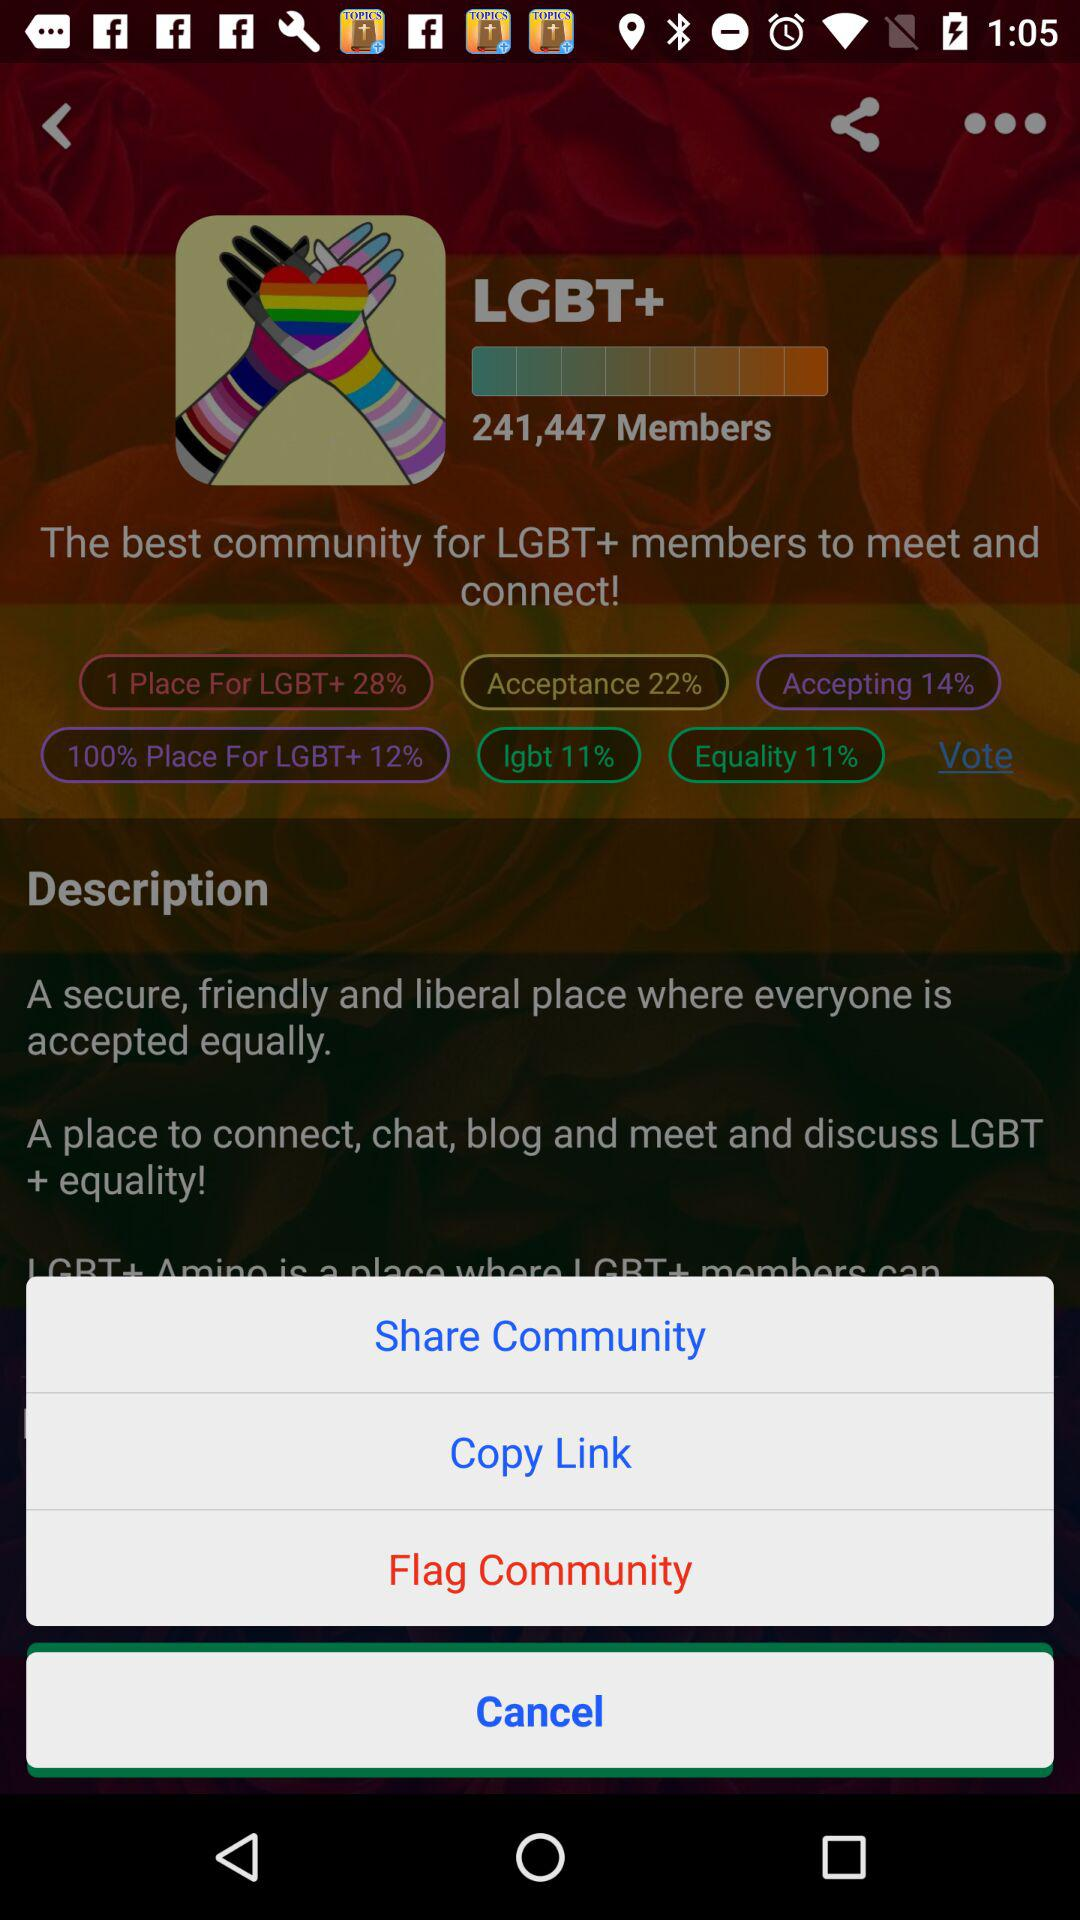How many more people are in the LGBT+ community than the LGBT community?
Answer the question using a single word or phrase. 241,447 